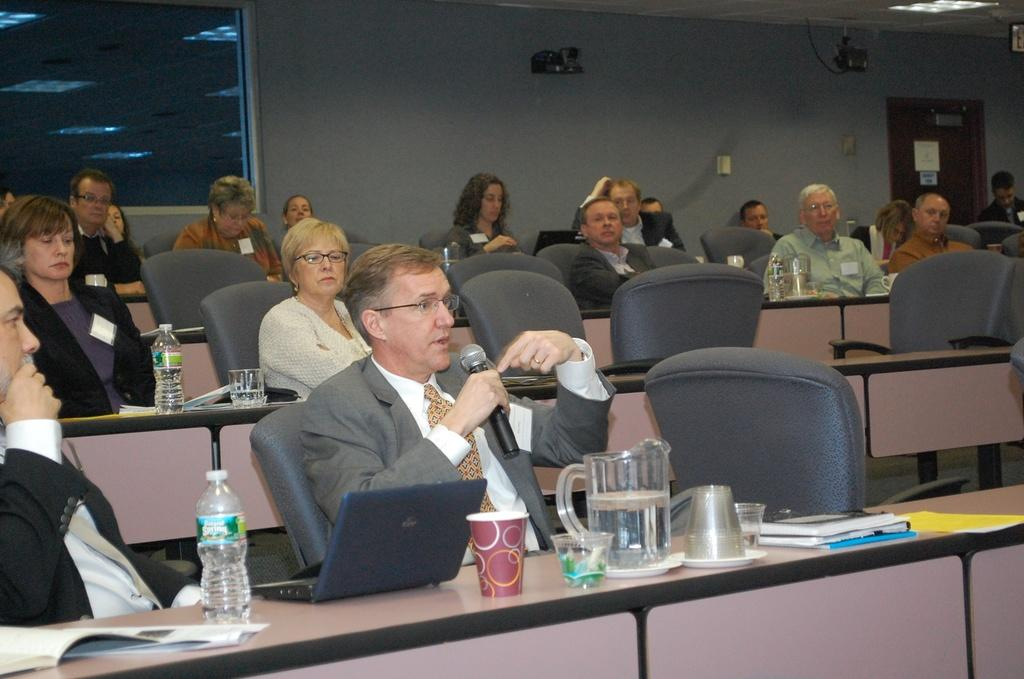What are the people in the image doing? The people in the image are sitting on chairs. Where are the chairs located in relation to the desk? The chairs are in front of the desk. What items can be seen on the desk? There are water bottles, glasses, and papers on the desk. What can be seen in the background of the image? There is a wall and a door in the background of the image. Can you see any kittens playing with a whip in the image? There are no kittens or whips present in the image. Is there a flight taking off in the background of the image? There is no flight or any indication of a flight taking off in the image. 